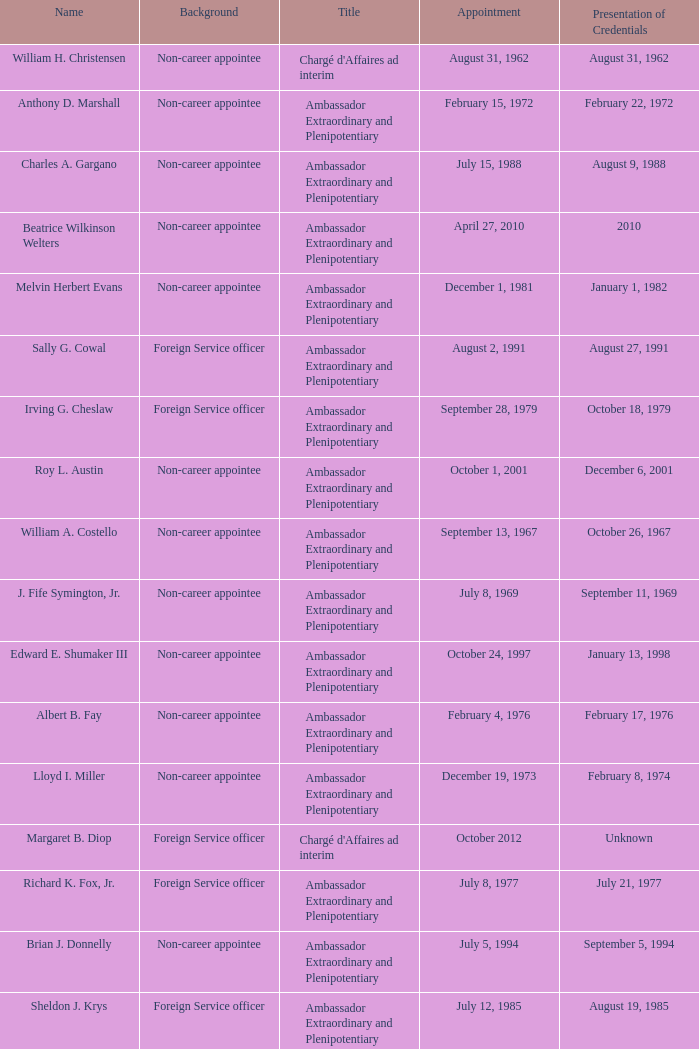When was william a. costello assigned? September 13, 1967. 